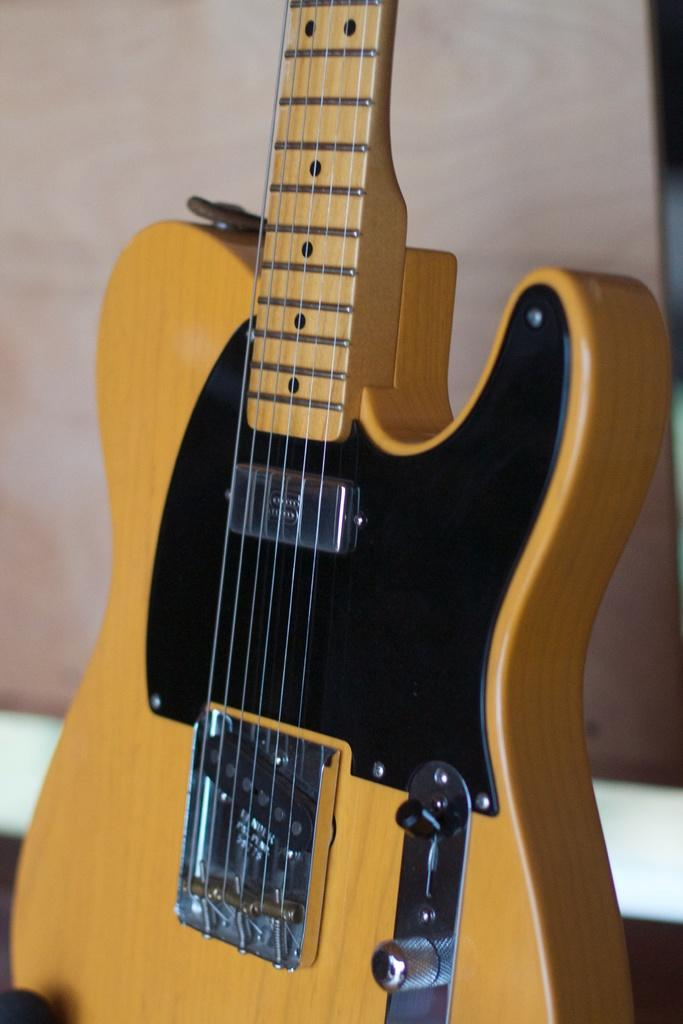What musical instrument is present in the image? There is a guitar in the image. What feature of the guitar is mentioned in the facts? The guitar has strings. What color are the strings on the guitar? The strings are yellow in color. What can be seen in the background of the image? There is a wall in the background of the image. Where is the goose standing in the image? There is no goose present in the image. What type of bait is used for fishing in the image? There is no fishing or bait present in the image. 